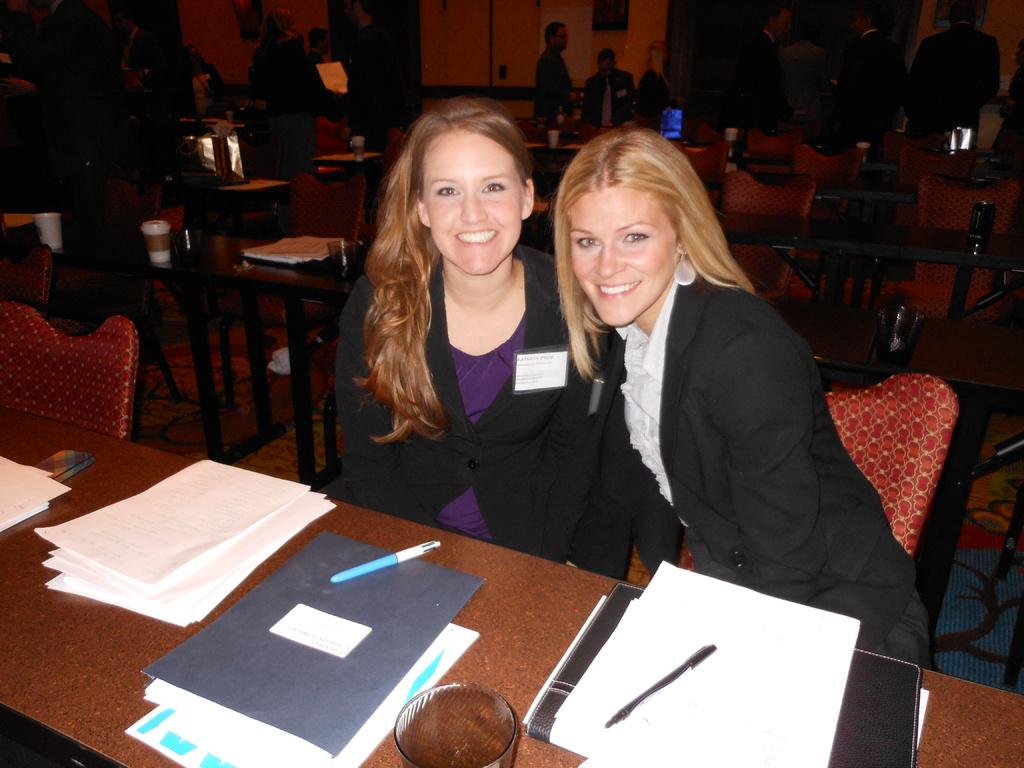How many women are in the image? There are two women in the image. What are the women doing in the image? The women are sitting on chairs and smiling. What is in front of the women? There is a table in front of the women. What items can be seen on the table? There are papers, books, and pens on the table. What type of beam is holding up the ceiling in the image? There is no mention of a ceiling or any beams in the image; it only features two women sitting at a table with papers, books, and pens. 